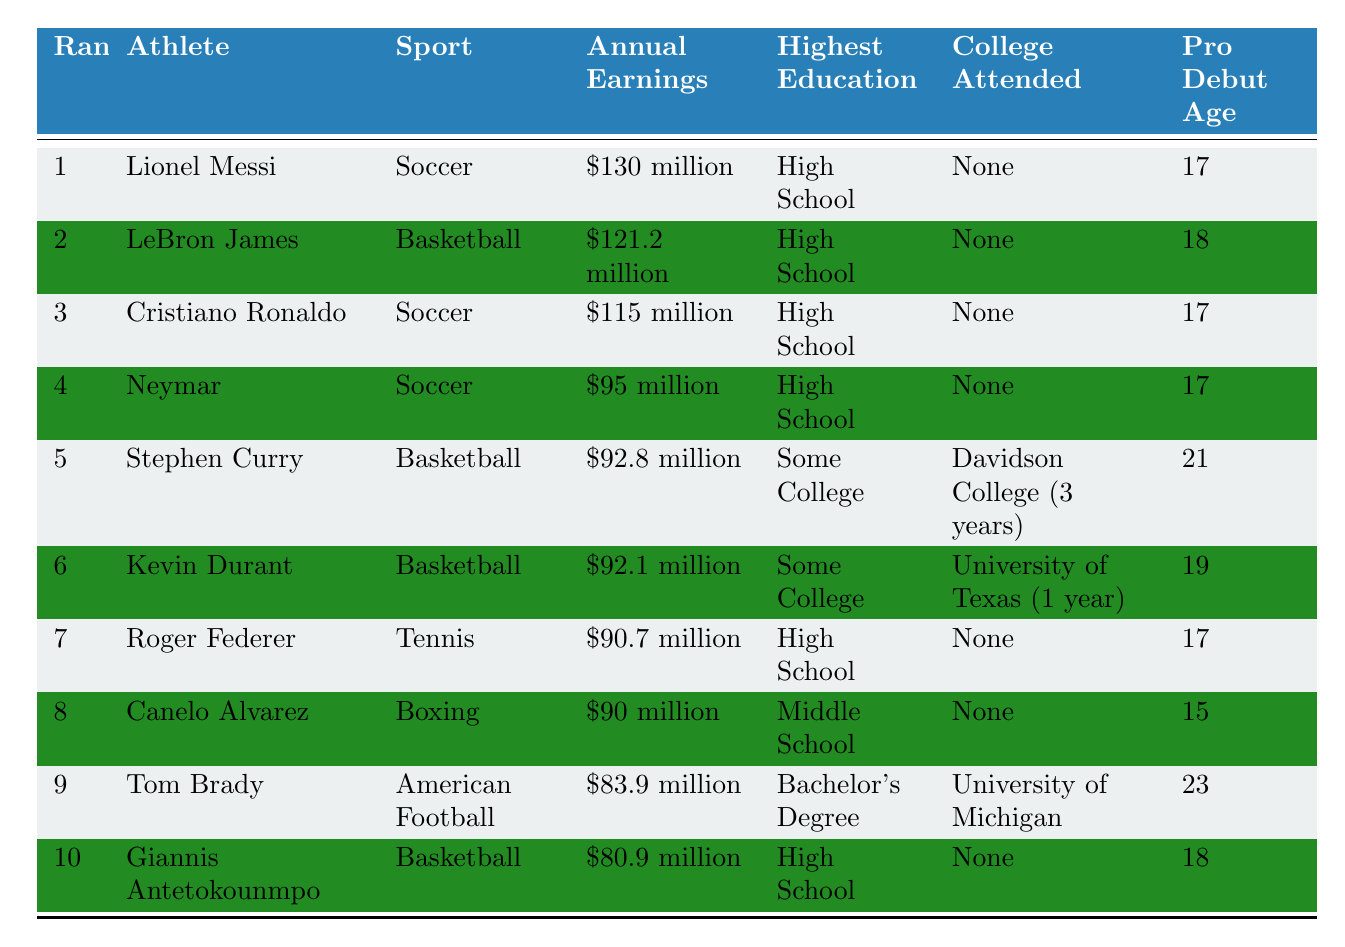What is the highest annual earnings among the athletes listed? Looking at the "Annual Earnings" column, Lionel Messi has the highest earnings at $130 million.
Answer: $130 million How many athletes have a highest education level of "High School"? Counting the entries under "Highest Education," there are 6 athletes with "High School" as their highest education level.
Answer: 6 Which athlete has the highest education level, and what is that level? The highest education level is a "Bachelor's Degree," held by Tom Brady.
Answer: Tom Brady, Bachelor's Degree What is the difference in annual earnings between the top-ranked athlete and the athlete in the fifth position? The top athlete, Lionel Messi, earns $130 million, and the fifth athlete, Stephen Curry, earns $92.8 million. The difference is $130 million - $92.8 million = $37.2 million.
Answer: $37.2 million Is there any athlete on the list who attended college? Reviewing the "College Attended" column, Stephen Curry and Kevin Durant attended college, while the others did not.
Answer: Yes Which sport does the athlete with the lowest annual earnings compete in? The athlete with the lowest earnings is Giannis Antetokounmpo, who competes in basketball.
Answer: Basketball How many athletes turned professional at the age of 17? Looking at the "Pro Debut Age" column, four athletes (Lionel Messi, Cristiano Ronaldo, Neymar, Roger Federer) debited at age 17.
Answer: 4 What is the average annual earnings of athletes with "Some College" education? The annual earnings for Stephen Curry ($92.8 million) and Kevin Durant ($92.1 million) are $92.8 million + $92.1 million = $184.9 million. Dividing this by 2 gives an average of $184.9 million / 2 = $92.45 million.
Answer: $92.45 million Who are the two athletes above Tom Brady in rankings, and what are their earnings? The athletes above Tom Brady are Lionel Messi ($130 million) and LeBron James ($121.2 million).
Answer: Lionel Messi, $130 million; LeBron James, $121.2 million What fraction of the top 10 athletes have not attended college? There are 8 athletes who have not attended college out of 10 total athletes, so the fraction is 8/10 or simplified to 4/5.
Answer: 4/5 How does Canelo Alvarez’s earnings compare to that of the athlete with a Bachelor’s Degree? Canelo Alvarez earns $90 million, while Tom Brady, who has a Bachelor's Degree, earns $83.9 million. Canelo Alvarez earns more, as $90 million is greater than $83.9 million.
Answer: Canelo Alvarez earns more 